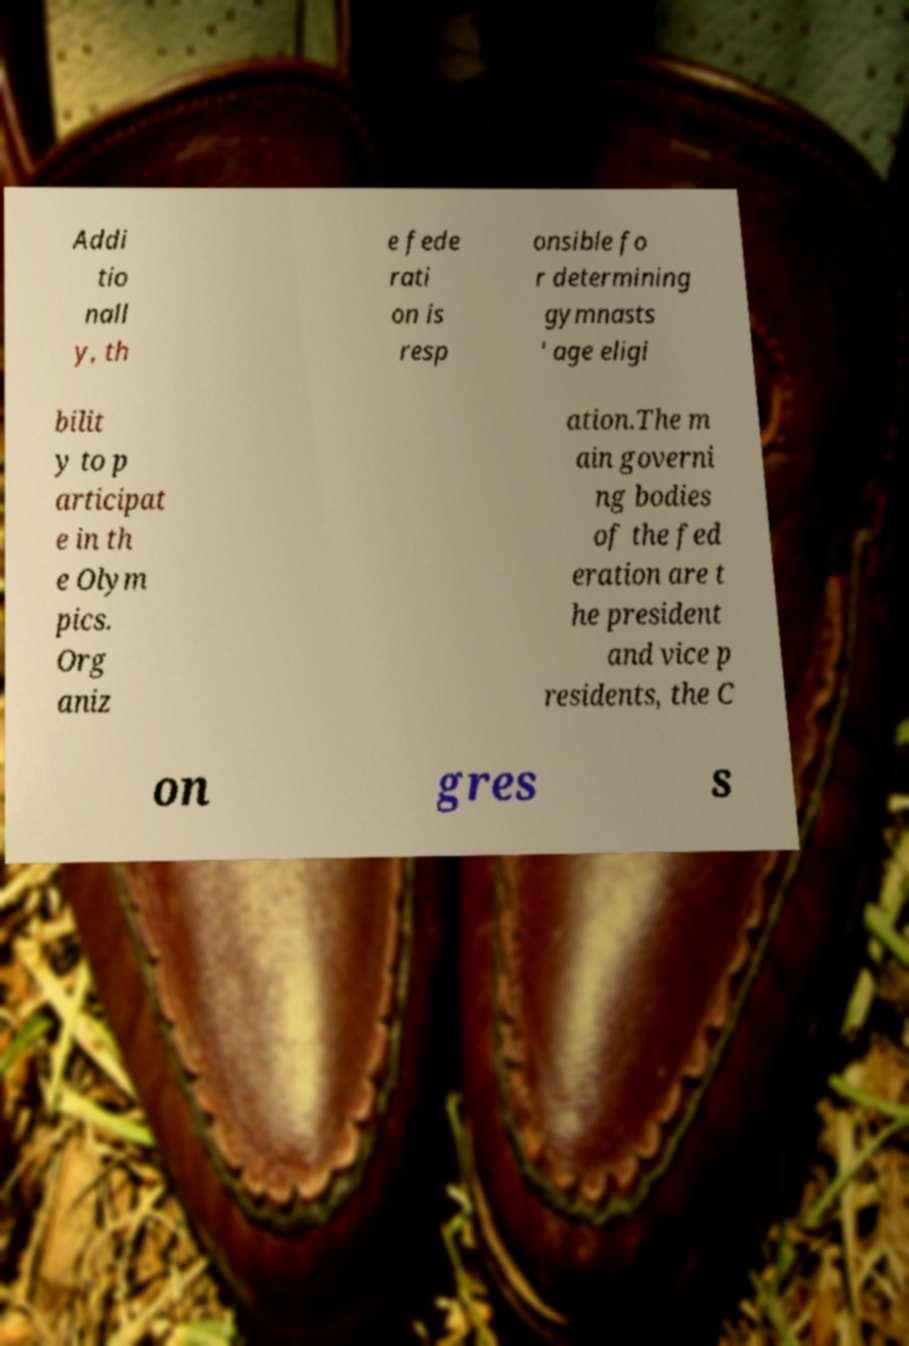Could you extract and type out the text from this image? Addi tio nall y, th e fede rati on is resp onsible fo r determining gymnasts ' age eligi bilit y to p articipat e in th e Olym pics. Org aniz ation.The m ain governi ng bodies of the fed eration are t he president and vice p residents, the C on gres s 